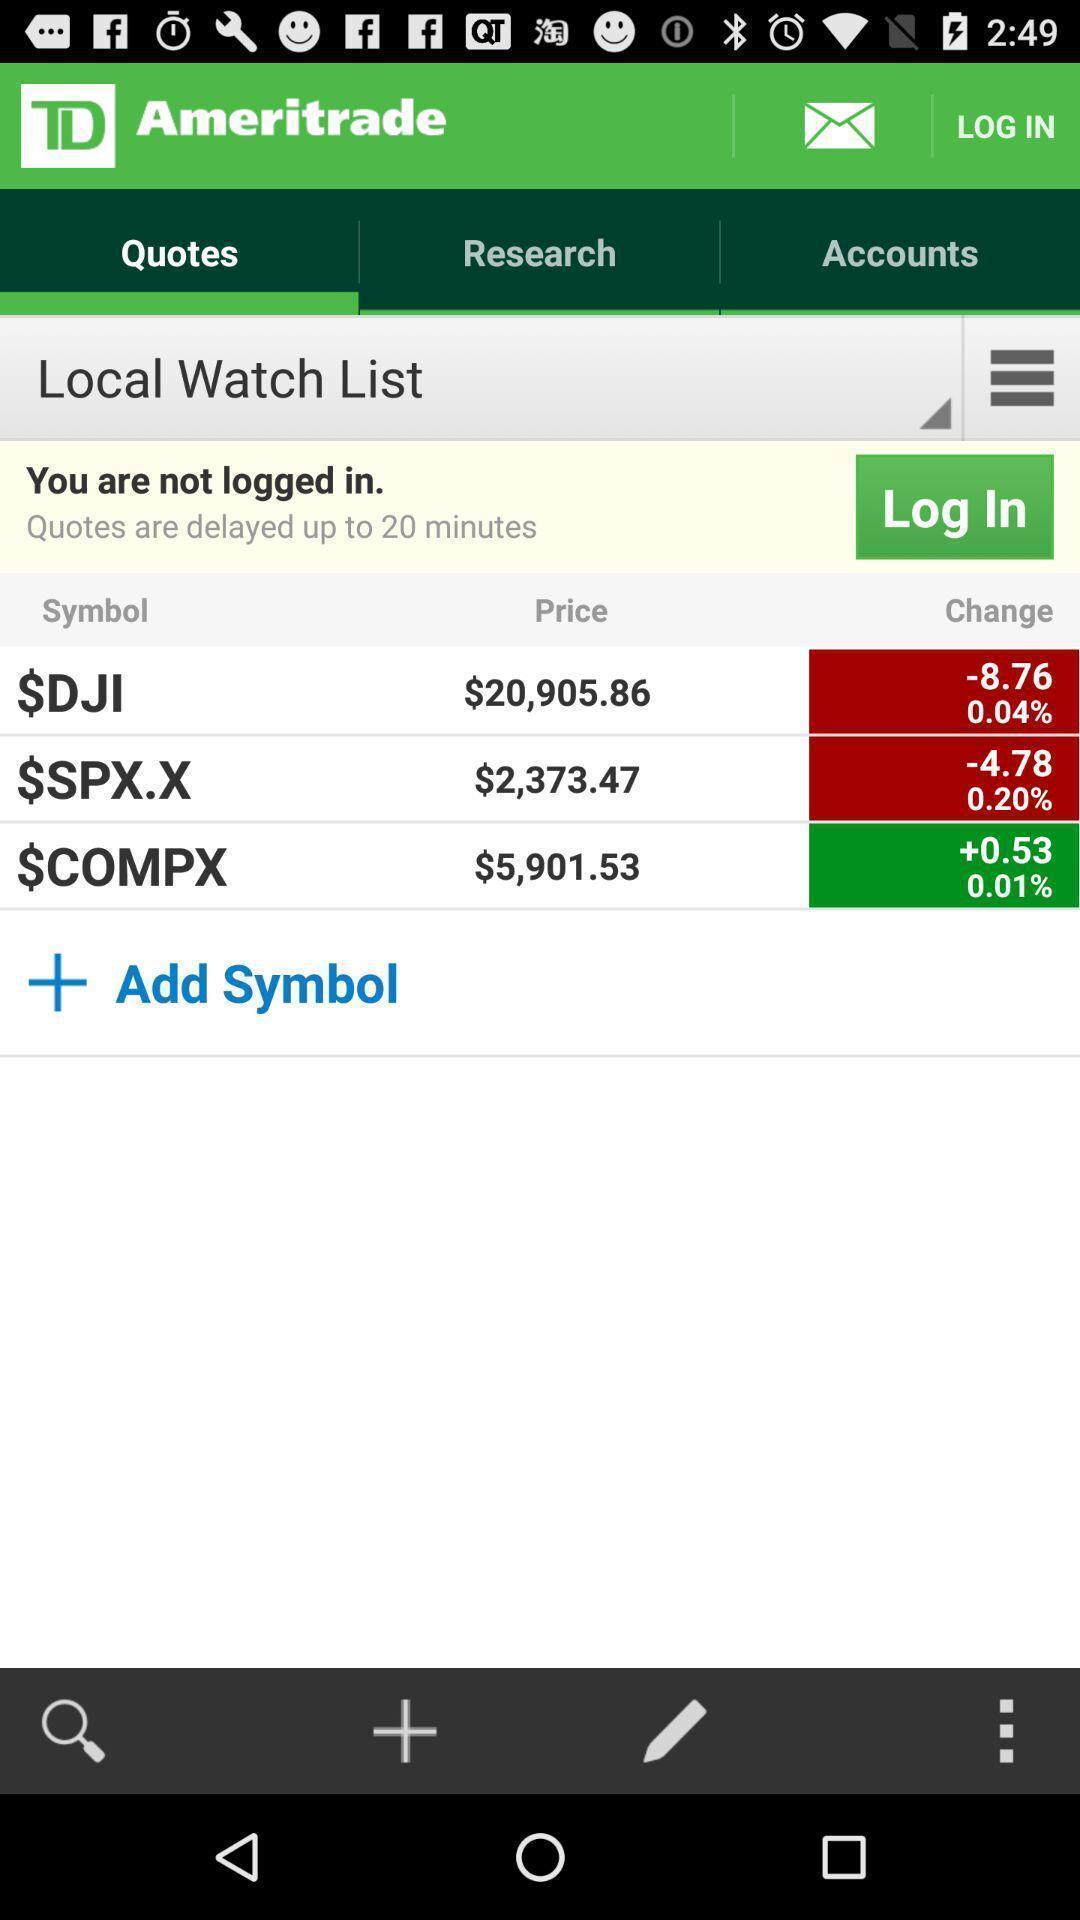Give me a summary of this screen capture. Screen displaying multiple controls and symbol options with price. 